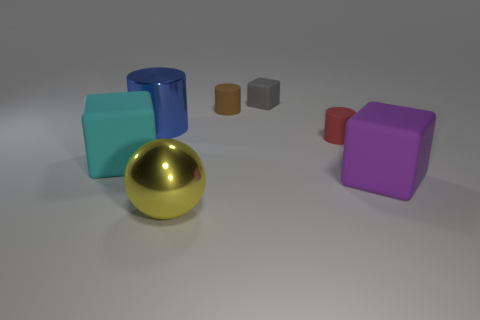Add 3 blue matte balls. How many objects exist? 10 Subtract all blocks. How many objects are left? 4 Subtract all gray rubber blocks. Subtract all blue cylinders. How many objects are left? 5 Add 4 yellow shiny things. How many yellow shiny things are left? 5 Add 3 large purple matte cubes. How many large purple matte cubes exist? 4 Subtract 0 brown spheres. How many objects are left? 7 